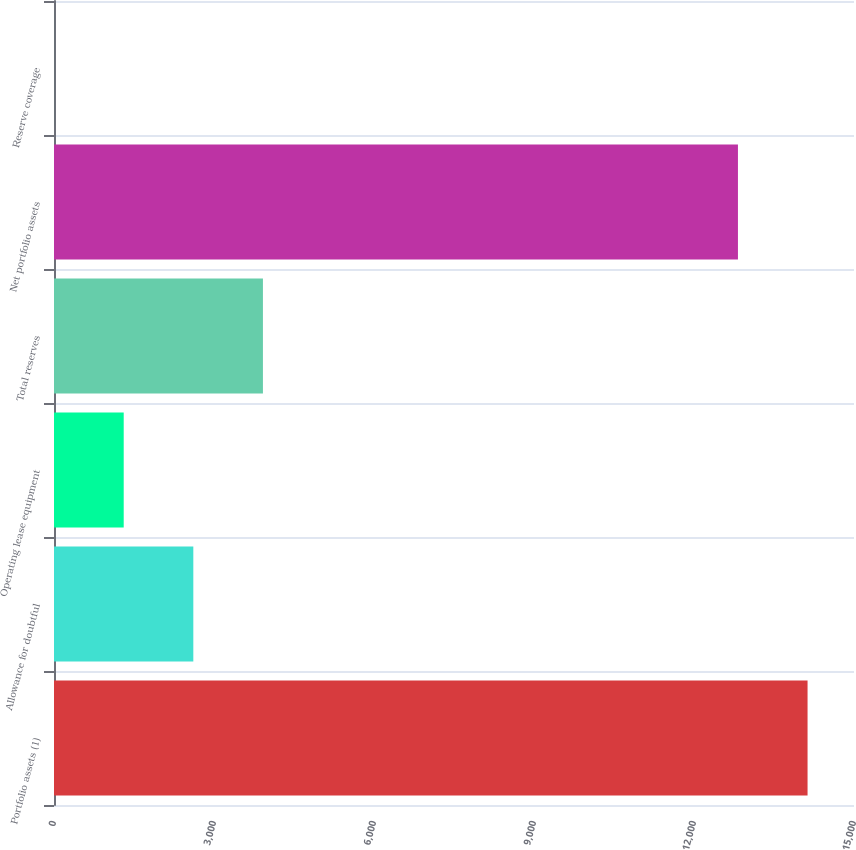Convert chart. <chart><loc_0><loc_0><loc_500><loc_500><bar_chart><fcel>Portfolio assets (1)<fcel>Allowance for doubtful<fcel>Operating lease equipment<fcel>Total reserves<fcel>Net portfolio assets<fcel>Reserve coverage<nl><fcel>14129.2<fcel>2612.24<fcel>1307.02<fcel>3917.46<fcel>12824<fcel>1.8<nl></chart> 